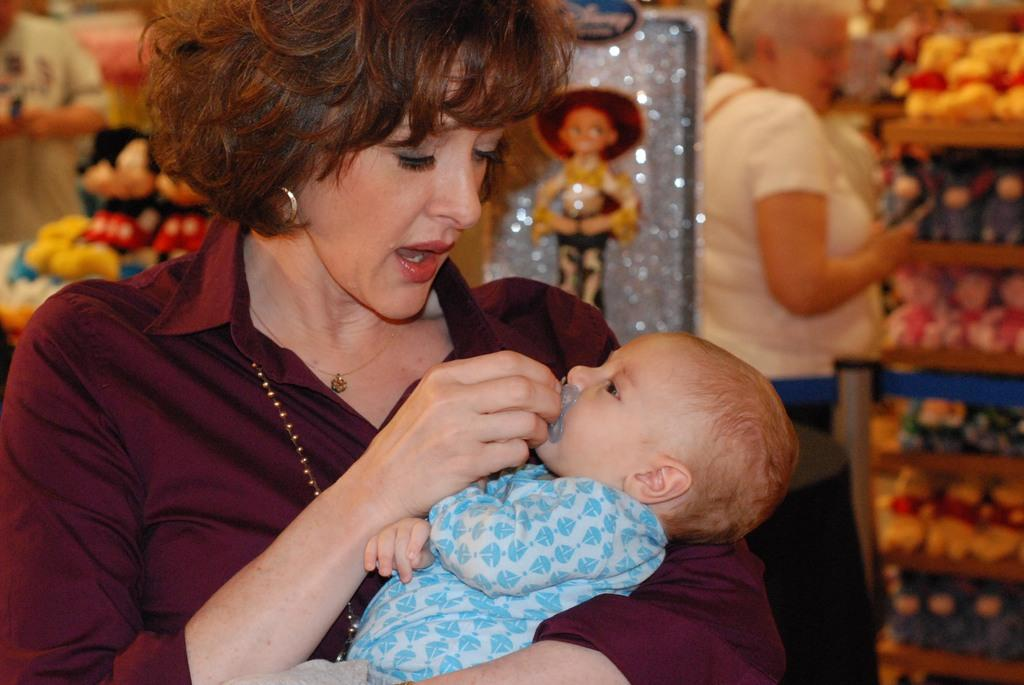What is the lady in the image holding? The lady is holding a baby in the image. What can be seen in the background of the image? There are toys and people standing in the background of the image. What type of island can be seen in the background of the image? There is no island present in the image; it features a lady holding a baby with toys and people in the background. 